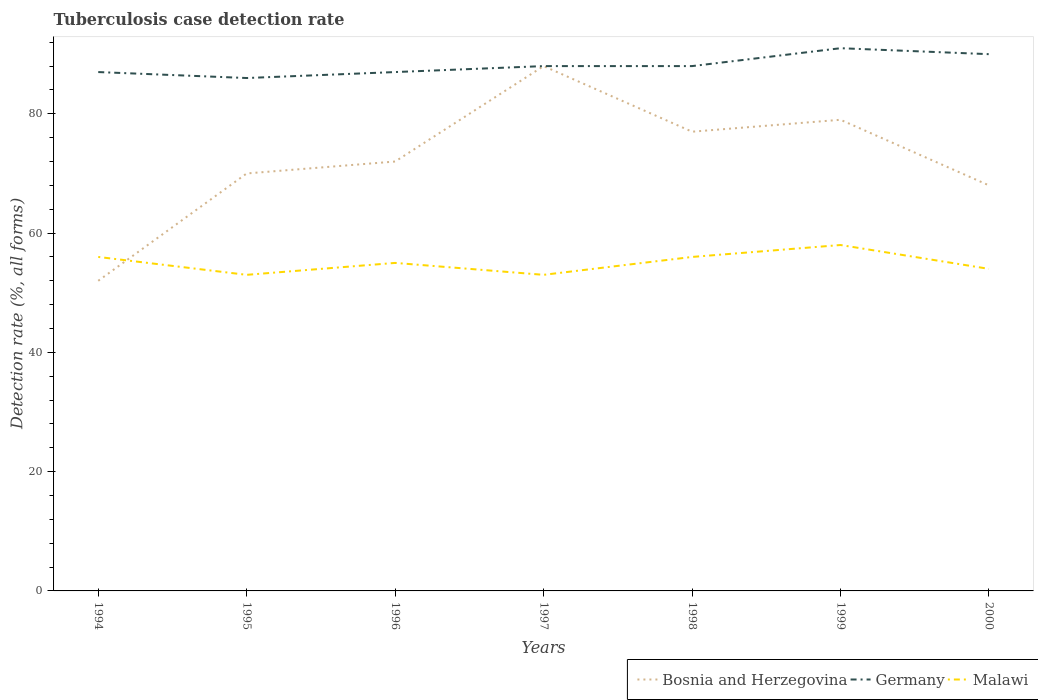Does the line corresponding to Germany intersect with the line corresponding to Malawi?
Keep it short and to the point. No. Across all years, what is the maximum tuberculosis case detection rate in in Germany?
Your answer should be very brief. 86. In which year was the tuberculosis case detection rate in in Bosnia and Herzegovina maximum?
Make the answer very short. 1994. What is the total tuberculosis case detection rate in in Germany in the graph?
Offer a very short reply. -5. What is the difference between the highest and the second highest tuberculosis case detection rate in in Germany?
Make the answer very short. 5. What is the difference between the highest and the lowest tuberculosis case detection rate in in Bosnia and Herzegovina?
Offer a terse response. 3. How many years are there in the graph?
Ensure brevity in your answer.  7. Are the values on the major ticks of Y-axis written in scientific E-notation?
Provide a succinct answer. No. How are the legend labels stacked?
Your response must be concise. Horizontal. What is the title of the graph?
Offer a terse response. Tuberculosis case detection rate. Does "OECD members" appear as one of the legend labels in the graph?
Your answer should be very brief. No. What is the label or title of the Y-axis?
Provide a succinct answer. Detection rate (%, all forms). What is the Detection rate (%, all forms) in Bosnia and Herzegovina in 1994?
Offer a terse response. 52. What is the Detection rate (%, all forms) in Germany in 1994?
Your answer should be compact. 87. What is the Detection rate (%, all forms) in Malawi in 1994?
Your answer should be compact. 56. What is the Detection rate (%, all forms) of Bosnia and Herzegovina in 1996?
Make the answer very short. 72. What is the Detection rate (%, all forms) of Malawi in 1996?
Provide a succinct answer. 55. What is the Detection rate (%, all forms) of Bosnia and Herzegovina in 1999?
Provide a short and direct response. 79. What is the Detection rate (%, all forms) of Germany in 1999?
Make the answer very short. 91. What is the Detection rate (%, all forms) in Bosnia and Herzegovina in 2000?
Make the answer very short. 68. What is the Detection rate (%, all forms) of Germany in 2000?
Provide a short and direct response. 90. Across all years, what is the maximum Detection rate (%, all forms) in Germany?
Your answer should be very brief. 91. Across all years, what is the maximum Detection rate (%, all forms) of Malawi?
Your answer should be very brief. 58. What is the total Detection rate (%, all forms) in Bosnia and Herzegovina in the graph?
Make the answer very short. 506. What is the total Detection rate (%, all forms) of Germany in the graph?
Ensure brevity in your answer.  617. What is the total Detection rate (%, all forms) of Malawi in the graph?
Provide a short and direct response. 385. What is the difference between the Detection rate (%, all forms) in Bosnia and Herzegovina in 1994 and that in 1995?
Your answer should be very brief. -18. What is the difference between the Detection rate (%, all forms) in Germany in 1994 and that in 1995?
Offer a very short reply. 1. What is the difference between the Detection rate (%, all forms) in Bosnia and Herzegovina in 1994 and that in 1996?
Make the answer very short. -20. What is the difference between the Detection rate (%, all forms) of Germany in 1994 and that in 1996?
Keep it short and to the point. 0. What is the difference between the Detection rate (%, all forms) of Malawi in 1994 and that in 1996?
Your answer should be compact. 1. What is the difference between the Detection rate (%, all forms) in Bosnia and Herzegovina in 1994 and that in 1997?
Ensure brevity in your answer.  -36. What is the difference between the Detection rate (%, all forms) of Malawi in 1994 and that in 1998?
Provide a succinct answer. 0. What is the difference between the Detection rate (%, all forms) of Bosnia and Herzegovina in 1994 and that in 1999?
Make the answer very short. -27. What is the difference between the Detection rate (%, all forms) of Germany in 1994 and that in 1999?
Provide a short and direct response. -4. What is the difference between the Detection rate (%, all forms) of Bosnia and Herzegovina in 1994 and that in 2000?
Your answer should be very brief. -16. What is the difference between the Detection rate (%, all forms) in Germany in 1994 and that in 2000?
Provide a short and direct response. -3. What is the difference between the Detection rate (%, all forms) in Germany in 1995 and that in 1996?
Ensure brevity in your answer.  -1. What is the difference between the Detection rate (%, all forms) in Germany in 1995 and that in 1998?
Your response must be concise. -2. What is the difference between the Detection rate (%, all forms) in Malawi in 1995 and that in 1998?
Your response must be concise. -3. What is the difference between the Detection rate (%, all forms) in Bosnia and Herzegovina in 1995 and that in 1999?
Your answer should be compact. -9. What is the difference between the Detection rate (%, all forms) in Malawi in 1995 and that in 2000?
Your answer should be very brief. -1. What is the difference between the Detection rate (%, all forms) in Malawi in 1996 and that in 1997?
Provide a short and direct response. 2. What is the difference between the Detection rate (%, all forms) in Germany in 1996 and that in 1998?
Your answer should be very brief. -1. What is the difference between the Detection rate (%, all forms) in Malawi in 1996 and that in 1998?
Keep it short and to the point. -1. What is the difference between the Detection rate (%, all forms) in Bosnia and Herzegovina in 1996 and that in 1999?
Your answer should be very brief. -7. What is the difference between the Detection rate (%, all forms) of Malawi in 1996 and that in 1999?
Make the answer very short. -3. What is the difference between the Detection rate (%, all forms) of Germany in 1996 and that in 2000?
Offer a terse response. -3. What is the difference between the Detection rate (%, all forms) of Malawi in 1996 and that in 2000?
Provide a succinct answer. 1. What is the difference between the Detection rate (%, all forms) of Bosnia and Herzegovina in 1997 and that in 1998?
Provide a short and direct response. 11. What is the difference between the Detection rate (%, all forms) in Germany in 1997 and that in 1998?
Offer a very short reply. 0. What is the difference between the Detection rate (%, all forms) of Malawi in 1997 and that in 1998?
Your answer should be very brief. -3. What is the difference between the Detection rate (%, all forms) in Bosnia and Herzegovina in 1997 and that in 1999?
Your answer should be compact. 9. What is the difference between the Detection rate (%, all forms) in Malawi in 1997 and that in 1999?
Your answer should be compact. -5. What is the difference between the Detection rate (%, all forms) of Germany in 1997 and that in 2000?
Give a very brief answer. -2. What is the difference between the Detection rate (%, all forms) of Bosnia and Herzegovina in 1998 and that in 2000?
Your answer should be compact. 9. What is the difference between the Detection rate (%, all forms) in Malawi in 1998 and that in 2000?
Your answer should be very brief. 2. What is the difference between the Detection rate (%, all forms) of Bosnia and Herzegovina in 1999 and that in 2000?
Your answer should be compact. 11. What is the difference between the Detection rate (%, all forms) of Germany in 1999 and that in 2000?
Give a very brief answer. 1. What is the difference between the Detection rate (%, all forms) in Malawi in 1999 and that in 2000?
Ensure brevity in your answer.  4. What is the difference between the Detection rate (%, all forms) of Bosnia and Herzegovina in 1994 and the Detection rate (%, all forms) of Germany in 1995?
Offer a very short reply. -34. What is the difference between the Detection rate (%, all forms) of Bosnia and Herzegovina in 1994 and the Detection rate (%, all forms) of Malawi in 1995?
Your response must be concise. -1. What is the difference between the Detection rate (%, all forms) in Germany in 1994 and the Detection rate (%, all forms) in Malawi in 1995?
Offer a terse response. 34. What is the difference between the Detection rate (%, all forms) in Bosnia and Herzegovina in 1994 and the Detection rate (%, all forms) in Germany in 1996?
Make the answer very short. -35. What is the difference between the Detection rate (%, all forms) in Bosnia and Herzegovina in 1994 and the Detection rate (%, all forms) in Malawi in 1996?
Your answer should be compact. -3. What is the difference between the Detection rate (%, all forms) in Bosnia and Herzegovina in 1994 and the Detection rate (%, all forms) in Germany in 1997?
Provide a short and direct response. -36. What is the difference between the Detection rate (%, all forms) of Bosnia and Herzegovina in 1994 and the Detection rate (%, all forms) of Germany in 1998?
Provide a short and direct response. -36. What is the difference between the Detection rate (%, all forms) of Bosnia and Herzegovina in 1994 and the Detection rate (%, all forms) of Malawi in 1998?
Provide a short and direct response. -4. What is the difference between the Detection rate (%, all forms) in Bosnia and Herzegovina in 1994 and the Detection rate (%, all forms) in Germany in 1999?
Keep it short and to the point. -39. What is the difference between the Detection rate (%, all forms) of Bosnia and Herzegovina in 1994 and the Detection rate (%, all forms) of Germany in 2000?
Provide a short and direct response. -38. What is the difference between the Detection rate (%, all forms) of Bosnia and Herzegovina in 1995 and the Detection rate (%, all forms) of Germany in 1996?
Your answer should be compact. -17. What is the difference between the Detection rate (%, all forms) of Germany in 1995 and the Detection rate (%, all forms) of Malawi in 1996?
Offer a terse response. 31. What is the difference between the Detection rate (%, all forms) of Bosnia and Herzegovina in 1995 and the Detection rate (%, all forms) of Germany in 1997?
Give a very brief answer. -18. What is the difference between the Detection rate (%, all forms) in Germany in 1995 and the Detection rate (%, all forms) in Malawi in 1997?
Provide a succinct answer. 33. What is the difference between the Detection rate (%, all forms) of Bosnia and Herzegovina in 1995 and the Detection rate (%, all forms) of Germany in 1998?
Offer a very short reply. -18. What is the difference between the Detection rate (%, all forms) of Bosnia and Herzegovina in 1995 and the Detection rate (%, all forms) of Germany in 1999?
Provide a succinct answer. -21. What is the difference between the Detection rate (%, all forms) in Bosnia and Herzegovina in 1995 and the Detection rate (%, all forms) in Malawi in 1999?
Offer a terse response. 12. What is the difference between the Detection rate (%, all forms) in Germany in 1995 and the Detection rate (%, all forms) in Malawi in 2000?
Provide a short and direct response. 32. What is the difference between the Detection rate (%, all forms) of Bosnia and Herzegovina in 1996 and the Detection rate (%, all forms) of Germany in 1997?
Keep it short and to the point. -16. What is the difference between the Detection rate (%, all forms) in Germany in 1996 and the Detection rate (%, all forms) in Malawi in 1997?
Provide a succinct answer. 34. What is the difference between the Detection rate (%, all forms) of Bosnia and Herzegovina in 1996 and the Detection rate (%, all forms) of Germany in 1998?
Give a very brief answer. -16. What is the difference between the Detection rate (%, all forms) in Bosnia and Herzegovina in 1996 and the Detection rate (%, all forms) in Malawi in 1998?
Make the answer very short. 16. What is the difference between the Detection rate (%, all forms) of Germany in 1996 and the Detection rate (%, all forms) of Malawi in 1998?
Give a very brief answer. 31. What is the difference between the Detection rate (%, all forms) of Bosnia and Herzegovina in 1996 and the Detection rate (%, all forms) of Germany in 1999?
Provide a short and direct response. -19. What is the difference between the Detection rate (%, all forms) of Germany in 1996 and the Detection rate (%, all forms) of Malawi in 1999?
Your answer should be very brief. 29. What is the difference between the Detection rate (%, all forms) of Bosnia and Herzegovina in 1996 and the Detection rate (%, all forms) of Malawi in 2000?
Ensure brevity in your answer.  18. What is the difference between the Detection rate (%, all forms) in Germany in 1996 and the Detection rate (%, all forms) in Malawi in 2000?
Your answer should be compact. 33. What is the difference between the Detection rate (%, all forms) in Bosnia and Herzegovina in 1997 and the Detection rate (%, all forms) in Malawi in 1998?
Offer a terse response. 32. What is the difference between the Detection rate (%, all forms) of Bosnia and Herzegovina in 1997 and the Detection rate (%, all forms) of Germany in 1999?
Your response must be concise. -3. What is the difference between the Detection rate (%, all forms) of Germany in 1997 and the Detection rate (%, all forms) of Malawi in 1999?
Provide a short and direct response. 30. What is the difference between the Detection rate (%, all forms) of Germany in 1997 and the Detection rate (%, all forms) of Malawi in 2000?
Your response must be concise. 34. What is the difference between the Detection rate (%, all forms) of Germany in 1998 and the Detection rate (%, all forms) of Malawi in 2000?
Make the answer very short. 34. What is the difference between the Detection rate (%, all forms) of Bosnia and Herzegovina in 1999 and the Detection rate (%, all forms) of Germany in 2000?
Your answer should be compact. -11. What is the difference between the Detection rate (%, all forms) of Germany in 1999 and the Detection rate (%, all forms) of Malawi in 2000?
Your response must be concise. 37. What is the average Detection rate (%, all forms) in Bosnia and Herzegovina per year?
Ensure brevity in your answer.  72.29. What is the average Detection rate (%, all forms) of Germany per year?
Offer a very short reply. 88.14. What is the average Detection rate (%, all forms) in Malawi per year?
Ensure brevity in your answer.  55. In the year 1994, what is the difference between the Detection rate (%, all forms) of Bosnia and Herzegovina and Detection rate (%, all forms) of Germany?
Offer a very short reply. -35. In the year 1994, what is the difference between the Detection rate (%, all forms) of Bosnia and Herzegovina and Detection rate (%, all forms) of Malawi?
Ensure brevity in your answer.  -4. In the year 1995, what is the difference between the Detection rate (%, all forms) in Bosnia and Herzegovina and Detection rate (%, all forms) in Malawi?
Your response must be concise. 17. In the year 1995, what is the difference between the Detection rate (%, all forms) of Germany and Detection rate (%, all forms) of Malawi?
Provide a succinct answer. 33. In the year 1996, what is the difference between the Detection rate (%, all forms) of Bosnia and Herzegovina and Detection rate (%, all forms) of Malawi?
Give a very brief answer. 17. In the year 1997, what is the difference between the Detection rate (%, all forms) in Bosnia and Herzegovina and Detection rate (%, all forms) in Malawi?
Keep it short and to the point. 35. In the year 1997, what is the difference between the Detection rate (%, all forms) of Germany and Detection rate (%, all forms) of Malawi?
Give a very brief answer. 35. In the year 1998, what is the difference between the Detection rate (%, all forms) in Bosnia and Herzegovina and Detection rate (%, all forms) in Malawi?
Offer a very short reply. 21. In the year 2000, what is the difference between the Detection rate (%, all forms) of Bosnia and Herzegovina and Detection rate (%, all forms) of Germany?
Offer a very short reply. -22. What is the ratio of the Detection rate (%, all forms) of Bosnia and Herzegovina in 1994 to that in 1995?
Keep it short and to the point. 0.74. What is the ratio of the Detection rate (%, all forms) in Germany in 1994 to that in 1995?
Ensure brevity in your answer.  1.01. What is the ratio of the Detection rate (%, all forms) in Malawi in 1994 to that in 1995?
Offer a terse response. 1.06. What is the ratio of the Detection rate (%, all forms) of Bosnia and Herzegovina in 1994 to that in 1996?
Provide a short and direct response. 0.72. What is the ratio of the Detection rate (%, all forms) in Germany in 1994 to that in 1996?
Your answer should be compact. 1. What is the ratio of the Detection rate (%, all forms) in Malawi in 1994 to that in 1996?
Make the answer very short. 1.02. What is the ratio of the Detection rate (%, all forms) of Bosnia and Herzegovina in 1994 to that in 1997?
Give a very brief answer. 0.59. What is the ratio of the Detection rate (%, all forms) of Malawi in 1994 to that in 1997?
Offer a terse response. 1.06. What is the ratio of the Detection rate (%, all forms) in Bosnia and Herzegovina in 1994 to that in 1998?
Offer a terse response. 0.68. What is the ratio of the Detection rate (%, all forms) in Germany in 1994 to that in 1998?
Give a very brief answer. 0.99. What is the ratio of the Detection rate (%, all forms) in Bosnia and Herzegovina in 1994 to that in 1999?
Give a very brief answer. 0.66. What is the ratio of the Detection rate (%, all forms) of Germany in 1994 to that in 1999?
Ensure brevity in your answer.  0.96. What is the ratio of the Detection rate (%, all forms) of Malawi in 1994 to that in 1999?
Give a very brief answer. 0.97. What is the ratio of the Detection rate (%, all forms) of Bosnia and Herzegovina in 1994 to that in 2000?
Offer a very short reply. 0.76. What is the ratio of the Detection rate (%, all forms) of Germany in 1994 to that in 2000?
Your answer should be very brief. 0.97. What is the ratio of the Detection rate (%, all forms) in Malawi in 1994 to that in 2000?
Provide a succinct answer. 1.04. What is the ratio of the Detection rate (%, all forms) of Bosnia and Herzegovina in 1995 to that in 1996?
Your answer should be very brief. 0.97. What is the ratio of the Detection rate (%, all forms) in Malawi in 1995 to that in 1996?
Make the answer very short. 0.96. What is the ratio of the Detection rate (%, all forms) in Bosnia and Herzegovina in 1995 to that in 1997?
Provide a short and direct response. 0.8. What is the ratio of the Detection rate (%, all forms) in Germany in 1995 to that in 1997?
Keep it short and to the point. 0.98. What is the ratio of the Detection rate (%, all forms) in Germany in 1995 to that in 1998?
Your response must be concise. 0.98. What is the ratio of the Detection rate (%, all forms) of Malawi in 1995 to that in 1998?
Your answer should be very brief. 0.95. What is the ratio of the Detection rate (%, all forms) in Bosnia and Herzegovina in 1995 to that in 1999?
Your response must be concise. 0.89. What is the ratio of the Detection rate (%, all forms) of Germany in 1995 to that in 1999?
Your answer should be very brief. 0.95. What is the ratio of the Detection rate (%, all forms) in Malawi in 1995 to that in 1999?
Ensure brevity in your answer.  0.91. What is the ratio of the Detection rate (%, all forms) of Bosnia and Herzegovina in 1995 to that in 2000?
Give a very brief answer. 1.03. What is the ratio of the Detection rate (%, all forms) of Germany in 1995 to that in 2000?
Your response must be concise. 0.96. What is the ratio of the Detection rate (%, all forms) in Malawi in 1995 to that in 2000?
Provide a succinct answer. 0.98. What is the ratio of the Detection rate (%, all forms) of Bosnia and Herzegovina in 1996 to that in 1997?
Provide a short and direct response. 0.82. What is the ratio of the Detection rate (%, all forms) in Germany in 1996 to that in 1997?
Your answer should be very brief. 0.99. What is the ratio of the Detection rate (%, all forms) of Malawi in 1996 to that in 1997?
Offer a terse response. 1.04. What is the ratio of the Detection rate (%, all forms) in Bosnia and Herzegovina in 1996 to that in 1998?
Your answer should be compact. 0.94. What is the ratio of the Detection rate (%, all forms) in Malawi in 1996 to that in 1998?
Your answer should be very brief. 0.98. What is the ratio of the Detection rate (%, all forms) in Bosnia and Herzegovina in 1996 to that in 1999?
Offer a terse response. 0.91. What is the ratio of the Detection rate (%, all forms) of Germany in 1996 to that in 1999?
Your answer should be very brief. 0.96. What is the ratio of the Detection rate (%, all forms) of Malawi in 1996 to that in 1999?
Keep it short and to the point. 0.95. What is the ratio of the Detection rate (%, all forms) in Bosnia and Herzegovina in 1996 to that in 2000?
Ensure brevity in your answer.  1.06. What is the ratio of the Detection rate (%, all forms) in Germany in 1996 to that in 2000?
Provide a succinct answer. 0.97. What is the ratio of the Detection rate (%, all forms) of Malawi in 1996 to that in 2000?
Your answer should be very brief. 1.02. What is the ratio of the Detection rate (%, all forms) in Bosnia and Herzegovina in 1997 to that in 1998?
Ensure brevity in your answer.  1.14. What is the ratio of the Detection rate (%, all forms) in Germany in 1997 to that in 1998?
Give a very brief answer. 1. What is the ratio of the Detection rate (%, all forms) in Malawi in 1997 to that in 1998?
Give a very brief answer. 0.95. What is the ratio of the Detection rate (%, all forms) of Bosnia and Herzegovina in 1997 to that in 1999?
Ensure brevity in your answer.  1.11. What is the ratio of the Detection rate (%, all forms) of Malawi in 1997 to that in 1999?
Offer a very short reply. 0.91. What is the ratio of the Detection rate (%, all forms) of Bosnia and Herzegovina in 1997 to that in 2000?
Your answer should be very brief. 1.29. What is the ratio of the Detection rate (%, all forms) in Germany in 1997 to that in 2000?
Offer a terse response. 0.98. What is the ratio of the Detection rate (%, all forms) in Malawi in 1997 to that in 2000?
Your answer should be very brief. 0.98. What is the ratio of the Detection rate (%, all forms) in Bosnia and Herzegovina in 1998 to that in 1999?
Provide a short and direct response. 0.97. What is the ratio of the Detection rate (%, all forms) of Germany in 1998 to that in 1999?
Provide a short and direct response. 0.97. What is the ratio of the Detection rate (%, all forms) of Malawi in 1998 to that in 1999?
Your response must be concise. 0.97. What is the ratio of the Detection rate (%, all forms) in Bosnia and Herzegovina in 1998 to that in 2000?
Provide a short and direct response. 1.13. What is the ratio of the Detection rate (%, all forms) of Germany in 1998 to that in 2000?
Offer a very short reply. 0.98. What is the ratio of the Detection rate (%, all forms) in Malawi in 1998 to that in 2000?
Give a very brief answer. 1.04. What is the ratio of the Detection rate (%, all forms) in Bosnia and Herzegovina in 1999 to that in 2000?
Your answer should be compact. 1.16. What is the ratio of the Detection rate (%, all forms) in Germany in 1999 to that in 2000?
Your response must be concise. 1.01. What is the ratio of the Detection rate (%, all forms) of Malawi in 1999 to that in 2000?
Offer a very short reply. 1.07. What is the difference between the highest and the second highest Detection rate (%, all forms) of Germany?
Provide a short and direct response. 1. 